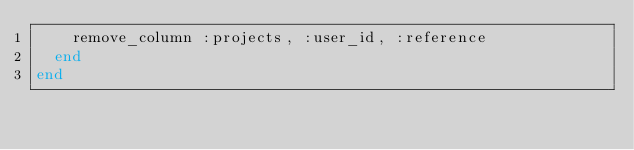Convert code to text. <code><loc_0><loc_0><loc_500><loc_500><_Ruby_>    remove_column :projects, :user_id, :reference
  end
end
</code> 